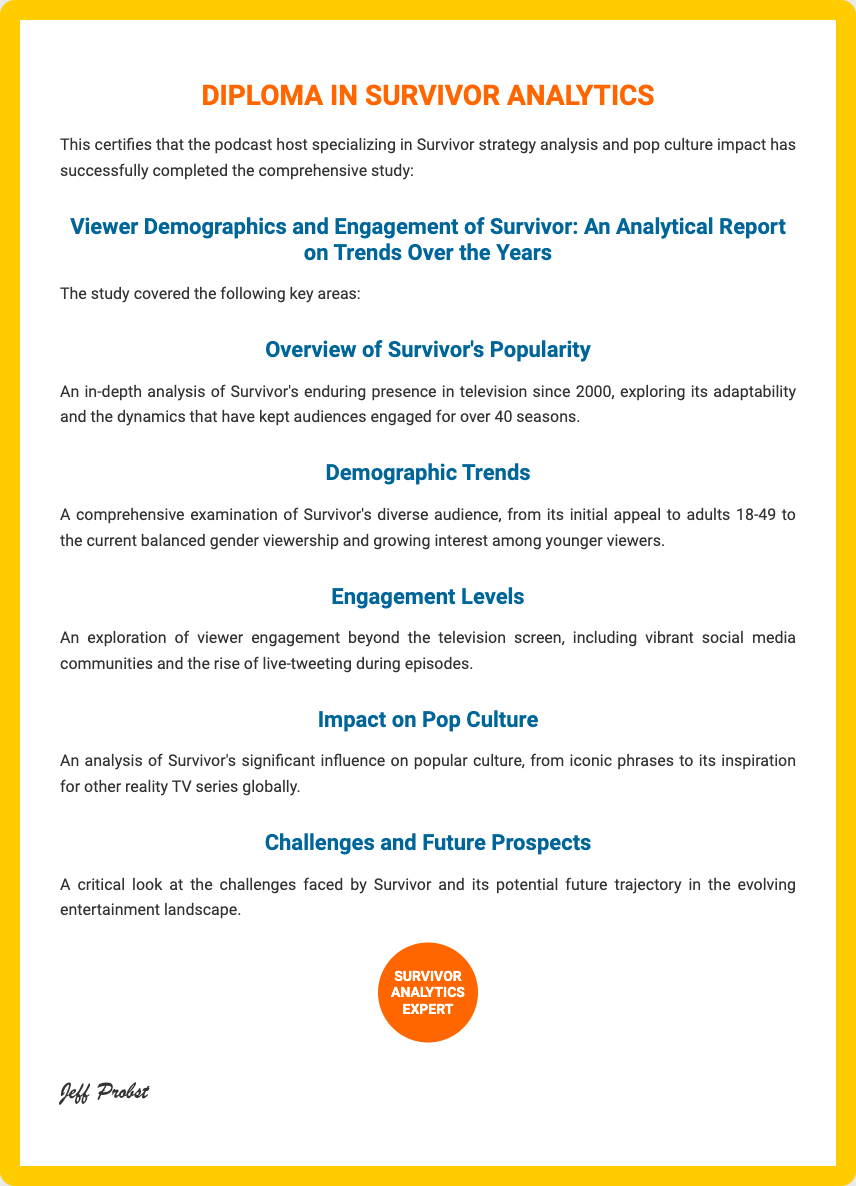What is the title of the study? The title of the study is a comprehensive examination highlighted in the document.
Answer: Viewer Demographics and Engagement of Survivor: An Analytical Report on Trends Over the Years In what year did Survivor first start airing? The document mentions Survivor's presence since 2000.
Answer: 2000 What demographics does the study cover? The document describes the diverse audience of Survivor, specifically mentioning gender and age groups.
Answer: Adults 18-49, balanced gender viewership, younger viewers What is one way viewers engage with Survivor beyond television? The document discusses viewer engagement that extends beyond just watching the show.
Answer: Social media communities What significant influence does Survivor have on popular culture? The document highlights the impact Survivor has had that extends into wider cultural significance.
Answer: Iconic phrases What is the main challenge mentioned for Survivor? The document indicates there are challenges faced by Survivor that are crucial for its future.
Answer: Challenges faced by Survivor 